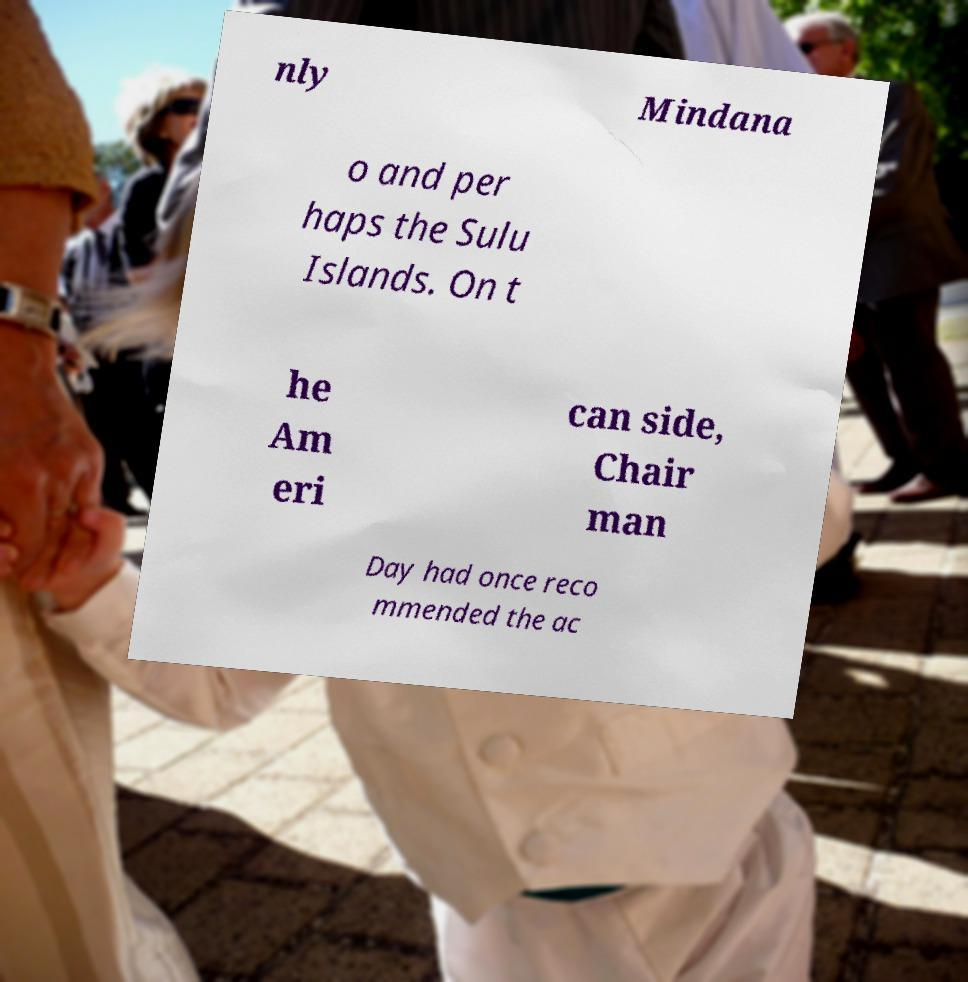Please read and relay the text visible in this image. What does it say? nly Mindana o and per haps the Sulu Islands. On t he Am eri can side, Chair man Day had once reco mmended the ac 